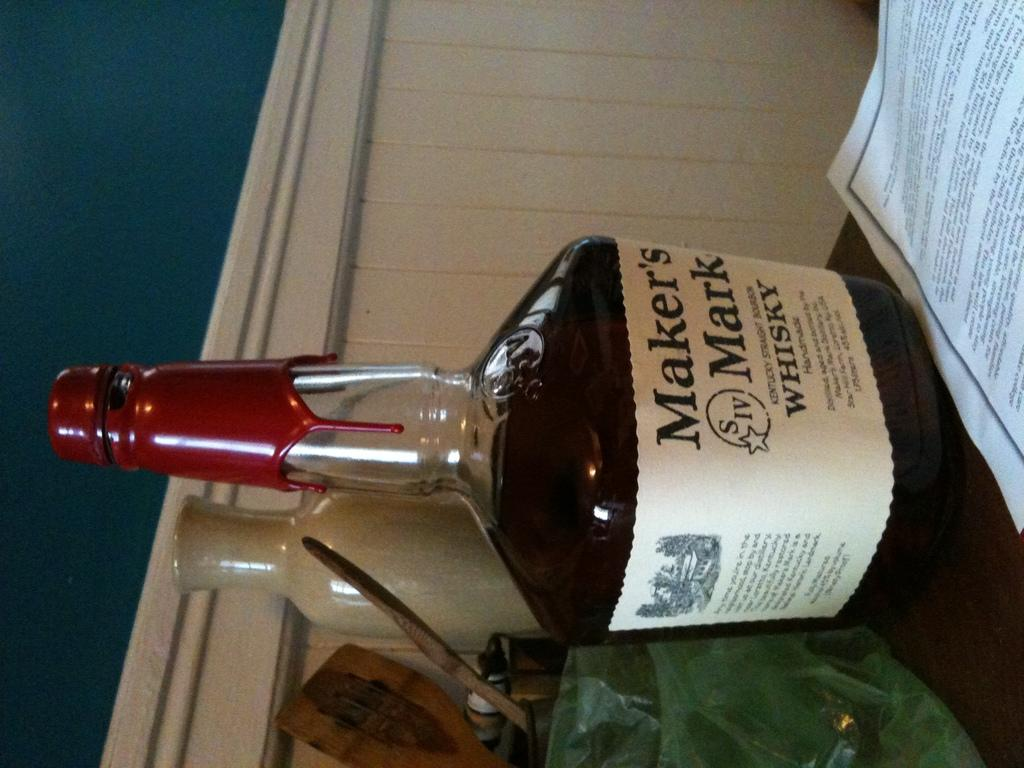<image>
Provide a brief description of the given image. Marker's Mark dark whisky in a white bottle with description and reddish cap 